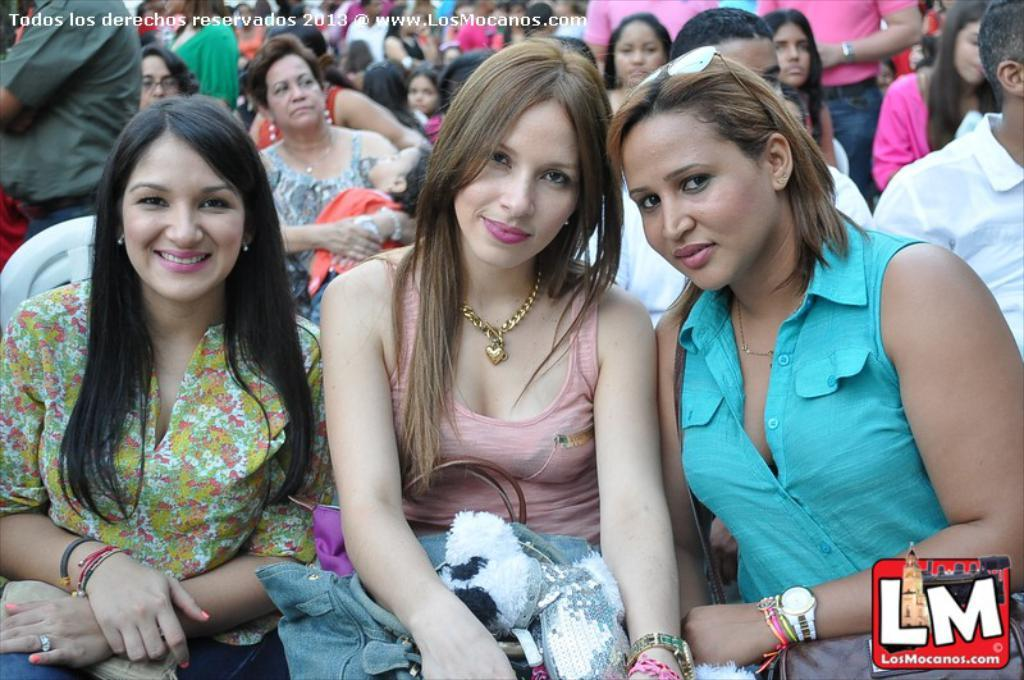How many women are in the image? There are three women in the image. What is the facial expression of the women? The women are smiling. What items can be seen in the image besides the women? There are bags, watches, and goggles in the image. Is there any text or symbol in the image? Yes, there is a logo in the image. What else can be seen in the background of the image? There is a group of people in the background of the image. What time of day is it in the image, and what type of paper is being used by the women? The time of day cannot be determined from the image, and there is no paper present in the image. 